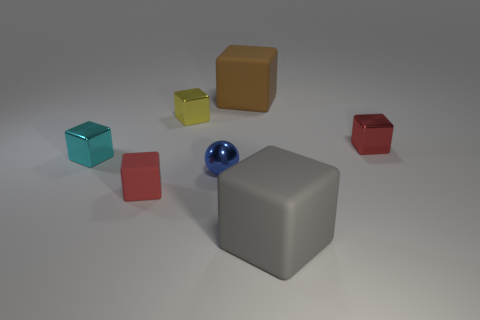Subtract all tiny red blocks. How many blocks are left? 4 Add 2 blue shiny balls. How many objects exist? 9 Subtract all tiny gray metal objects. Subtract all small cyan objects. How many objects are left? 6 Add 6 red shiny blocks. How many red shiny blocks are left? 7 Add 3 big blue balls. How many big blue balls exist? 3 Subtract all gray blocks. How many blocks are left? 5 Subtract 0 blue cylinders. How many objects are left? 7 Subtract all blocks. How many objects are left? 1 Subtract 3 blocks. How many blocks are left? 3 Subtract all blue cubes. Subtract all purple balls. How many cubes are left? 6 